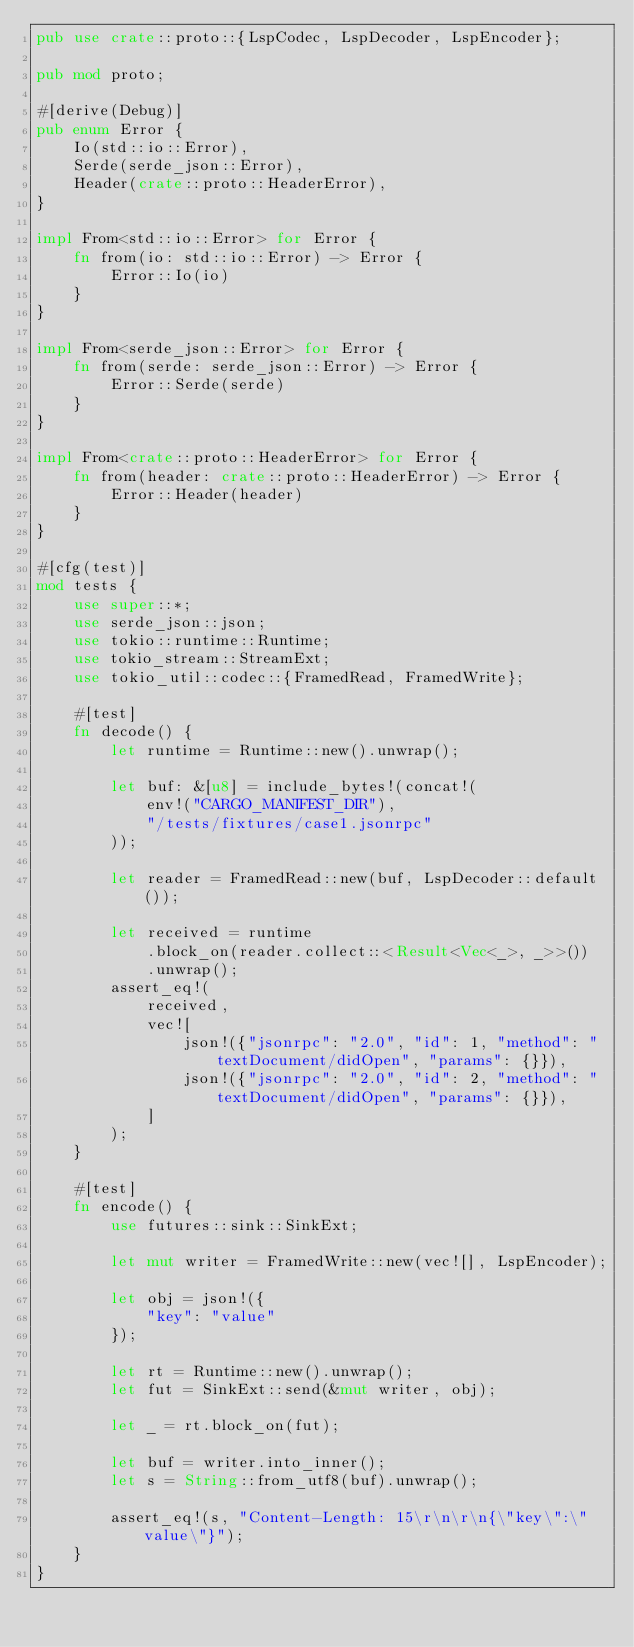Convert code to text. <code><loc_0><loc_0><loc_500><loc_500><_Rust_>pub use crate::proto::{LspCodec, LspDecoder, LspEncoder};

pub mod proto;

#[derive(Debug)]
pub enum Error {
    Io(std::io::Error),
    Serde(serde_json::Error),
    Header(crate::proto::HeaderError),
}

impl From<std::io::Error> for Error {
    fn from(io: std::io::Error) -> Error {
        Error::Io(io)
    }
}

impl From<serde_json::Error> for Error {
    fn from(serde: serde_json::Error) -> Error {
        Error::Serde(serde)
    }
}

impl From<crate::proto::HeaderError> for Error {
    fn from(header: crate::proto::HeaderError) -> Error {
        Error::Header(header)
    }
}

#[cfg(test)]
mod tests {
    use super::*;
    use serde_json::json;
    use tokio::runtime::Runtime;
    use tokio_stream::StreamExt;
    use tokio_util::codec::{FramedRead, FramedWrite};

    #[test]
    fn decode() {
        let runtime = Runtime::new().unwrap();

        let buf: &[u8] = include_bytes!(concat!(
            env!("CARGO_MANIFEST_DIR"),
            "/tests/fixtures/case1.jsonrpc"
        ));

        let reader = FramedRead::new(buf, LspDecoder::default());

        let received = runtime
            .block_on(reader.collect::<Result<Vec<_>, _>>())
            .unwrap();
        assert_eq!(
            received,
            vec![
                json!({"jsonrpc": "2.0", "id": 1, "method": "textDocument/didOpen", "params": {}}),
                json!({"jsonrpc": "2.0", "id": 2, "method": "textDocument/didOpen", "params": {}}),
            ]
        );
    }

    #[test]
    fn encode() {
        use futures::sink::SinkExt;

        let mut writer = FramedWrite::new(vec![], LspEncoder);

        let obj = json!({
            "key": "value"
        });

        let rt = Runtime::new().unwrap();
        let fut = SinkExt::send(&mut writer, obj);

        let _ = rt.block_on(fut);

        let buf = writer.into_inner();
        let s = String::from_utf8(buf).unwrap();

        assert_eq!(s, "Content-Length: 15\r\n\r\n{\"key\":\"value\"}");
    }
}
</code> 